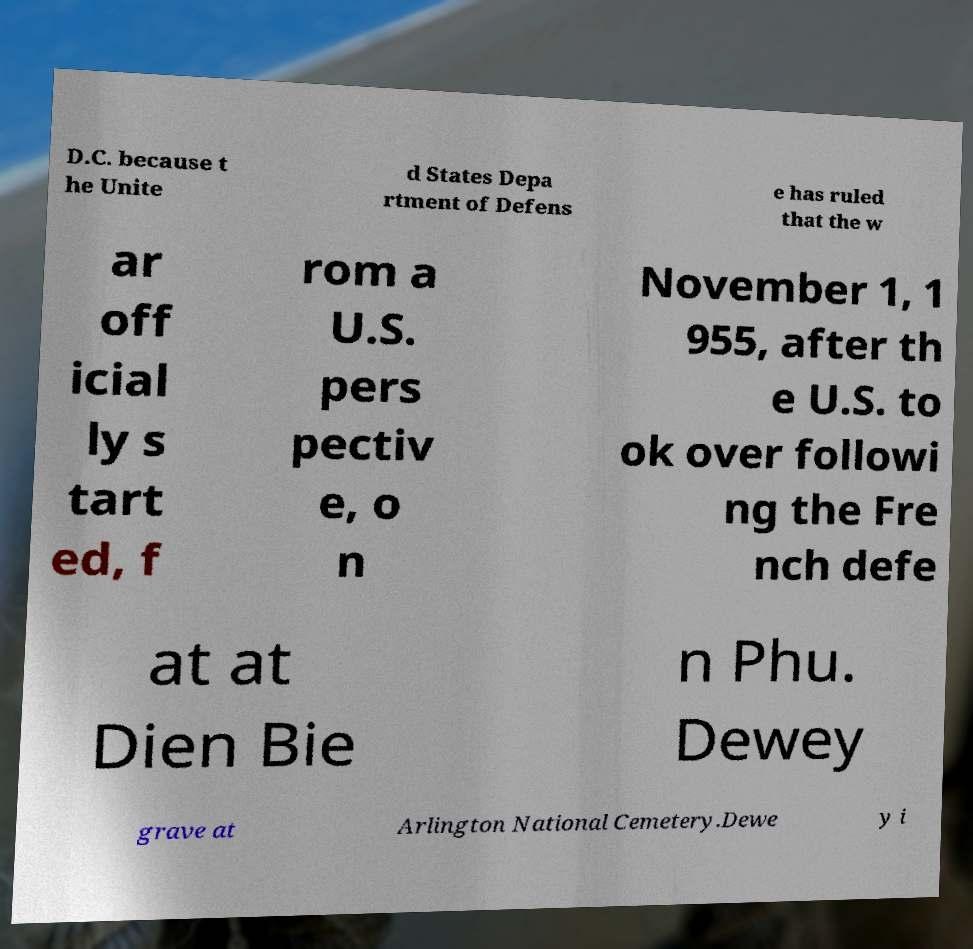Could you extract and type out the text from this image? D.C. because t he Unite d States Depa rtment of Defens e has ruled that the w ar off icial ly s tart ed, f rom a U.S. pers pectiv e, o n November 1, 1 955, after th e U.S. to ok over followi ng the Fre nch defe at at Dien Bie n Phu. Dewey grave at Arlington National Cemetery.Dewe y i 